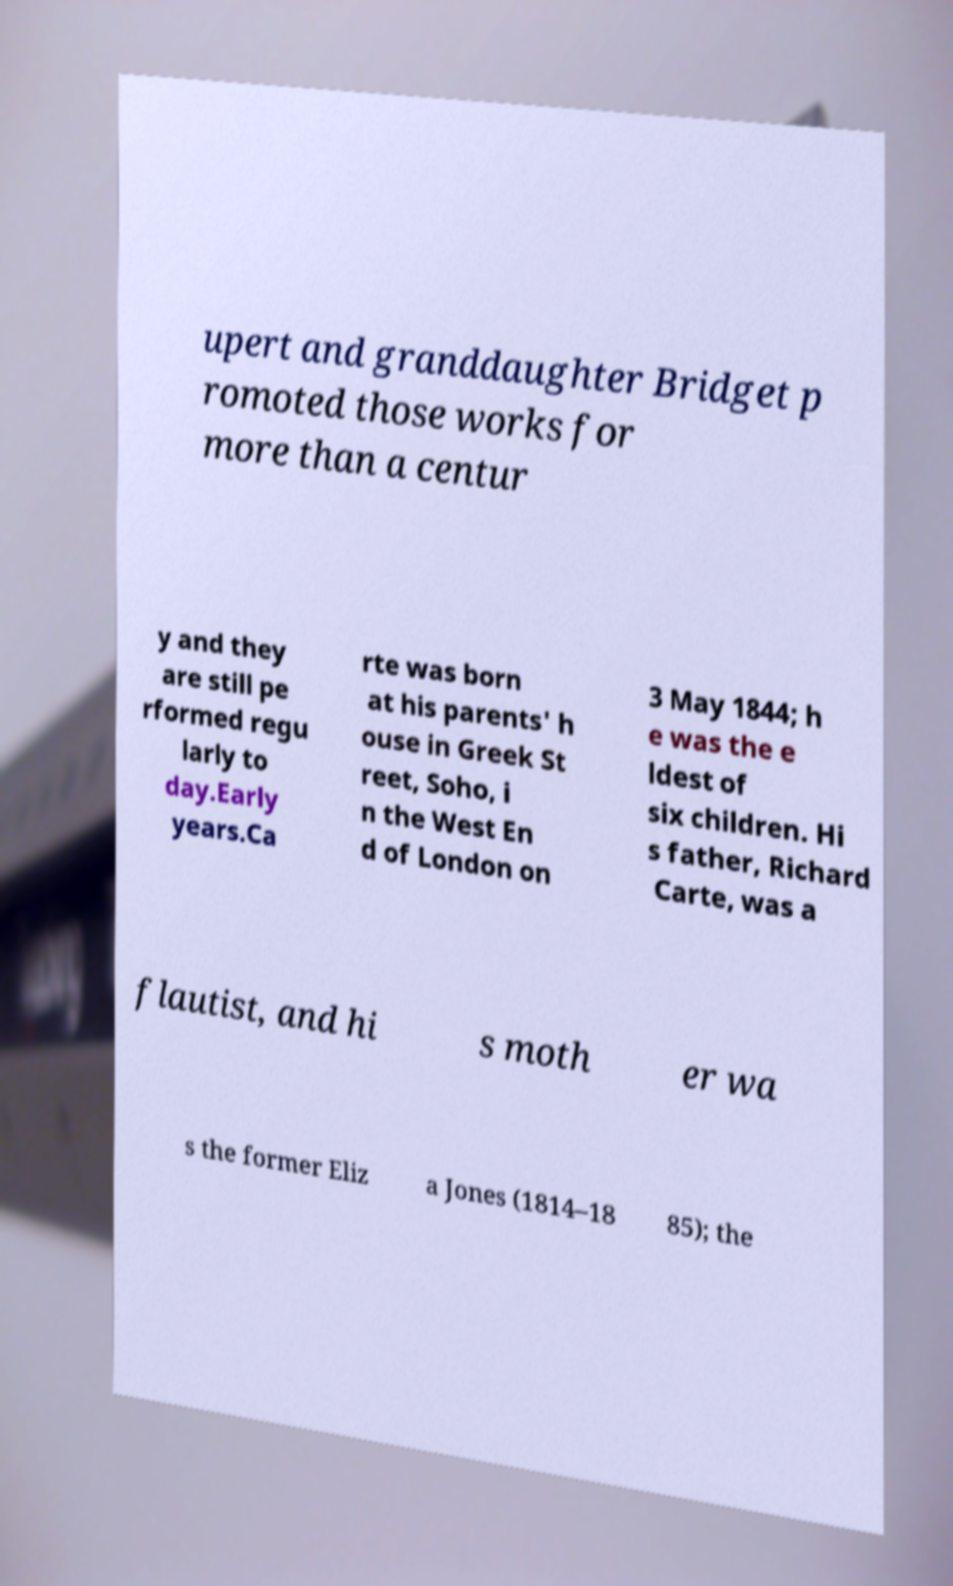What messages or text are displayed in this image? I need them in a readable, typed format. upert and granddaughter Bridget p romoted those works for more than a centur y and they are still pe rformed regu larly to day.Early years.Ca rte was born at his parents' h ouse in Greek St reet, Soho, i n the West En d of London on 3 May 1844; h e was the e ldest of six children. Hi s father, Richard Carte, was a flautist, and hi s moth er wa s the former Eliz a Jones (1814–18 85); the 